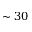<formula> <loc_0><loc_0><loc_500><loc_500>\sim 3 0</formula> 